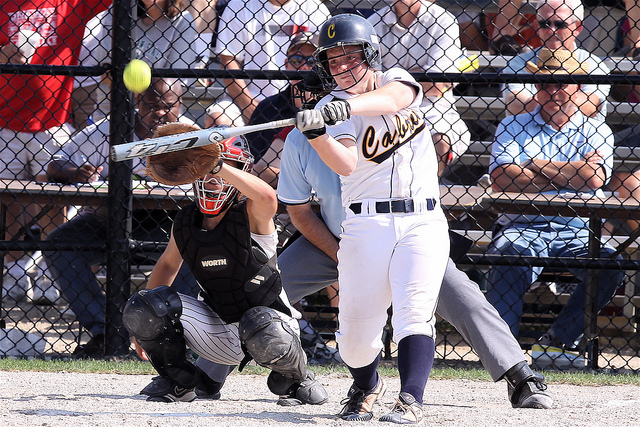Read and extract the text from this image. Cabre WORTH CF4 C 9 